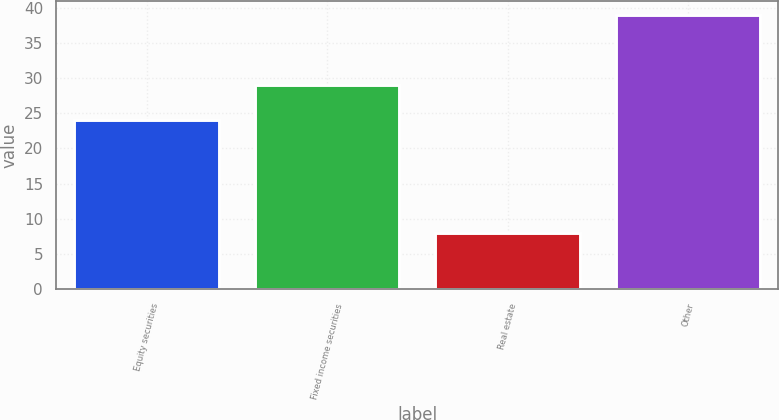<chart> <loc_0><loc_0><loc_500><loc_500><bar_chart><fcel>Equity securities<fcel>Fixed income securities<fcel>Real estate<fcel>Other<nl><fcel>24<fcel>29<fcel>8<fcel>39<nl></chart> 